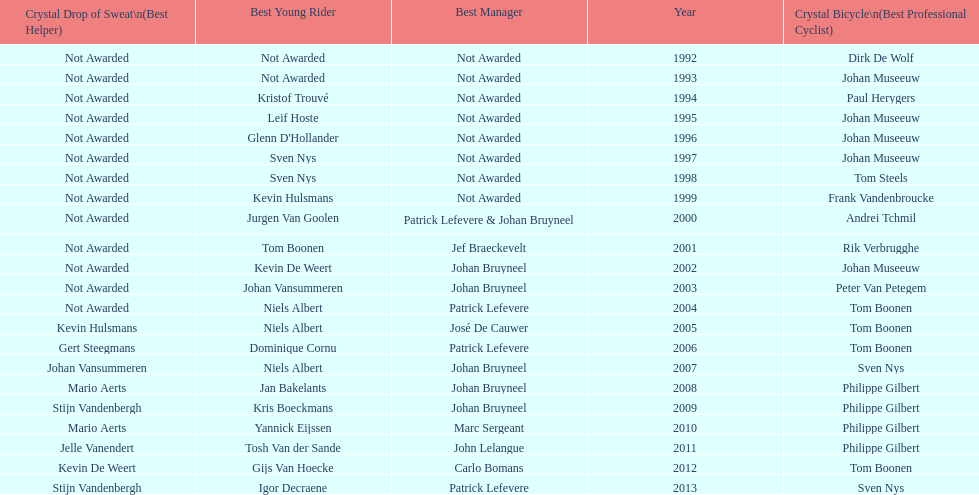What is the average number of times johan museeuw starred? 5. 